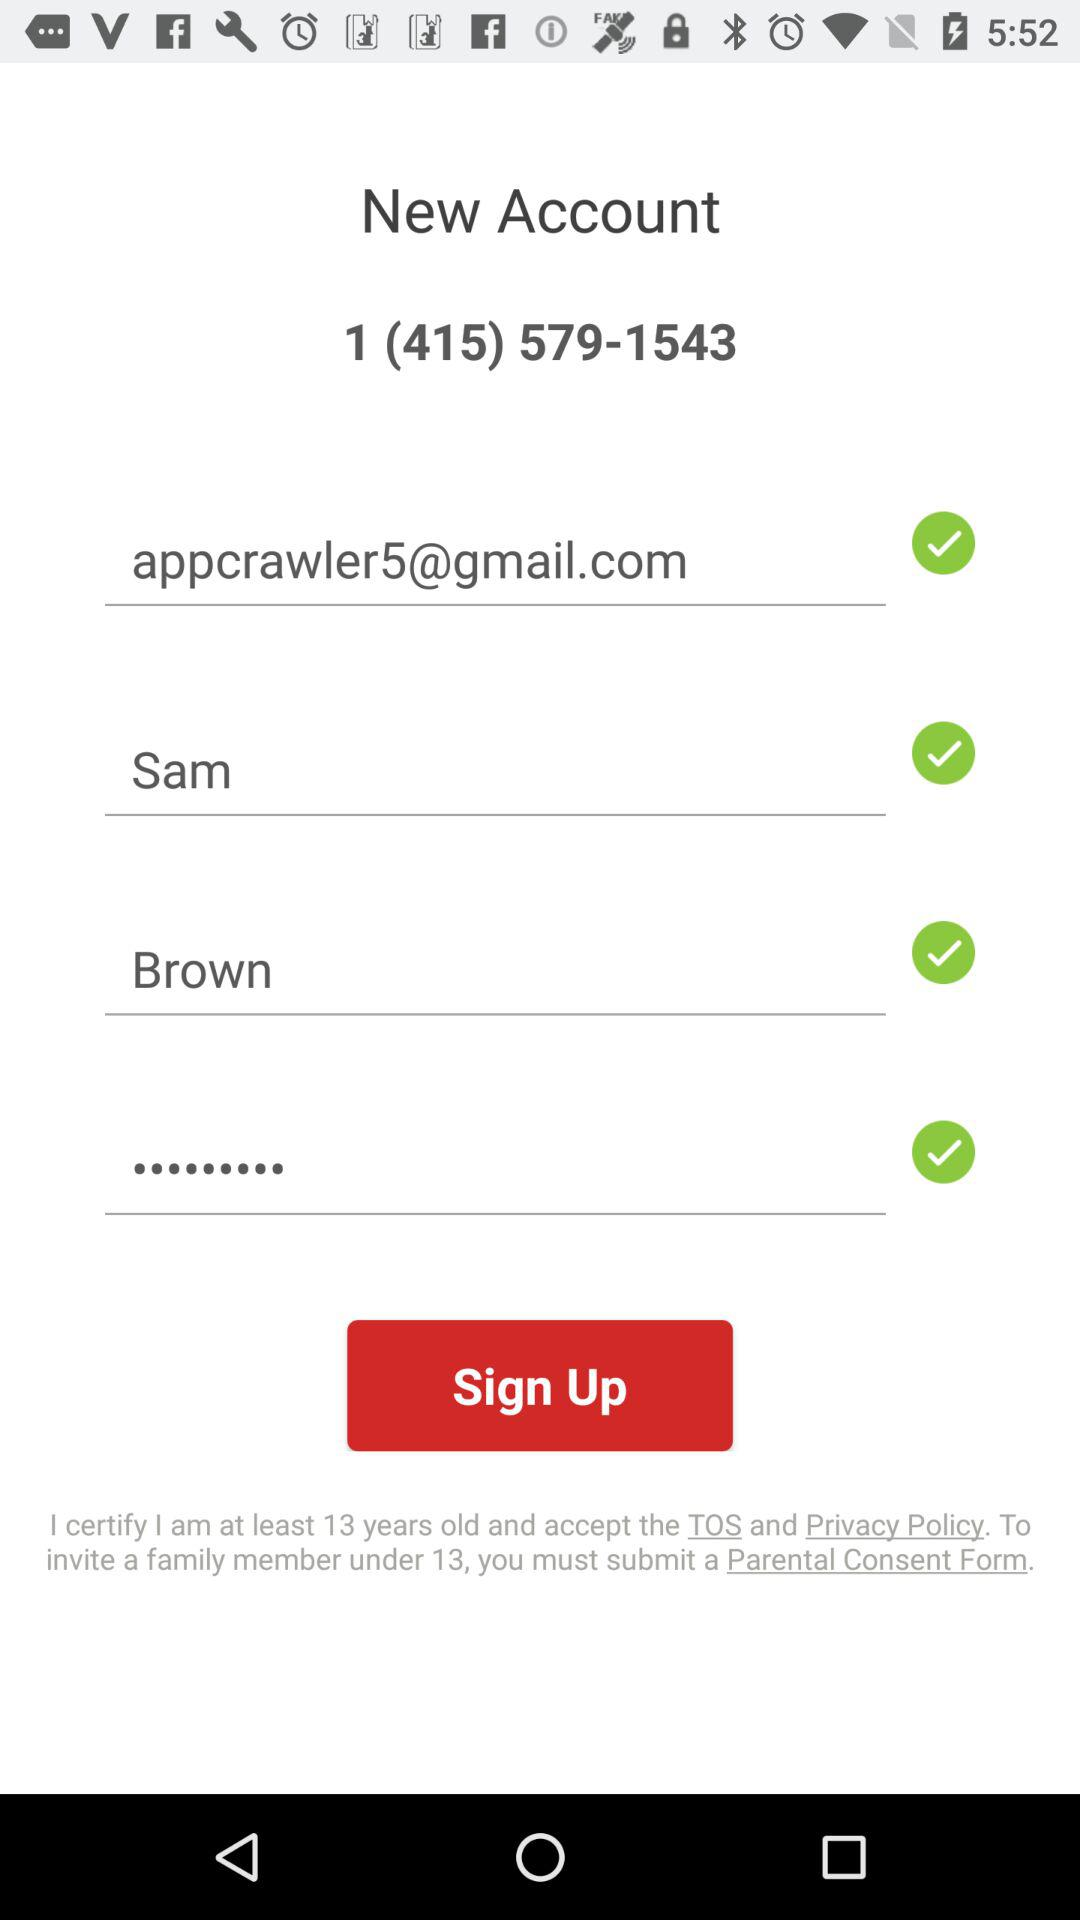What is the email address? The email address is appcrawler5@gmail.com. 